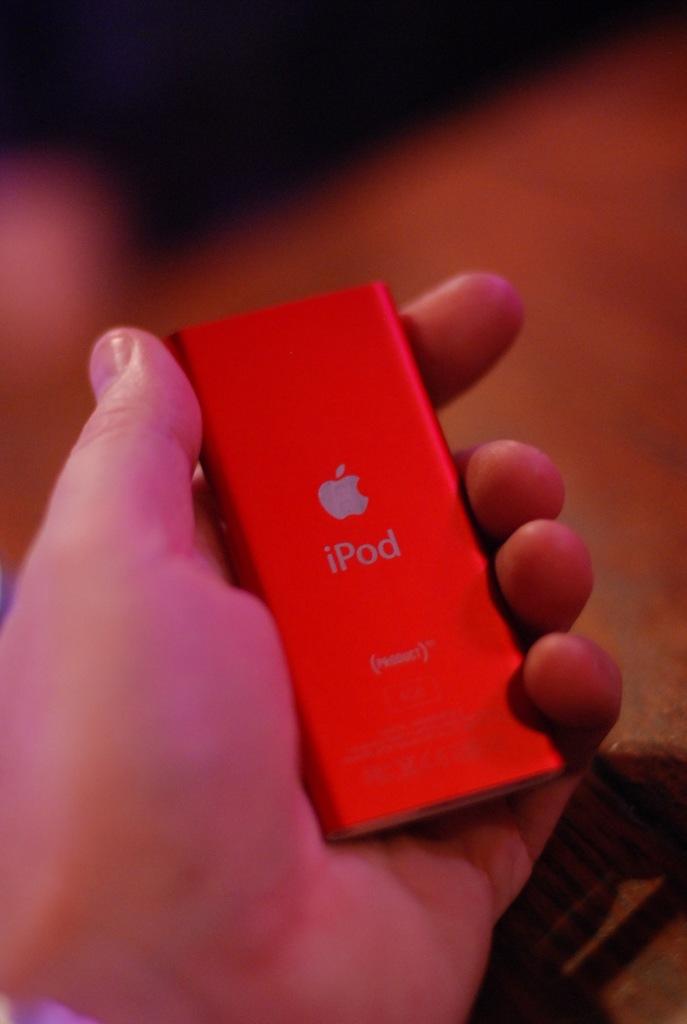Is this an apple ipod?
Offer a terse response. Yes. What is the device called?
Provide a succinct answer. Ipod. 